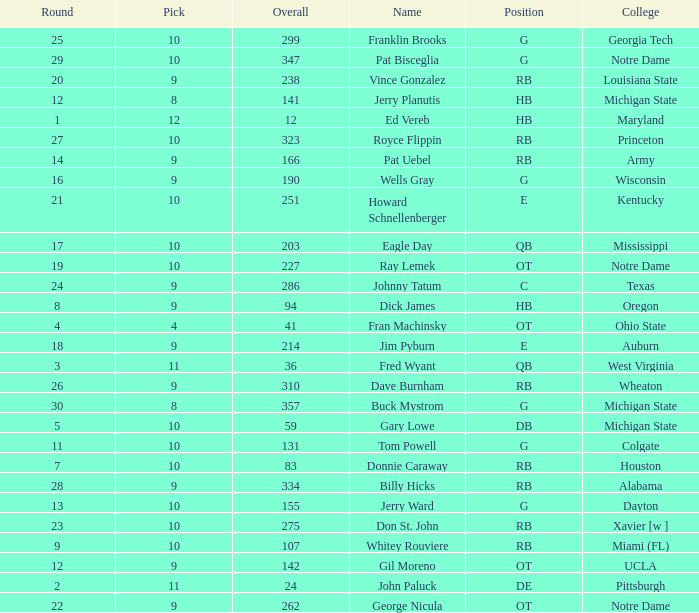What is the highest overall pick number for george nicula who had a pick smaller than 9? None. 